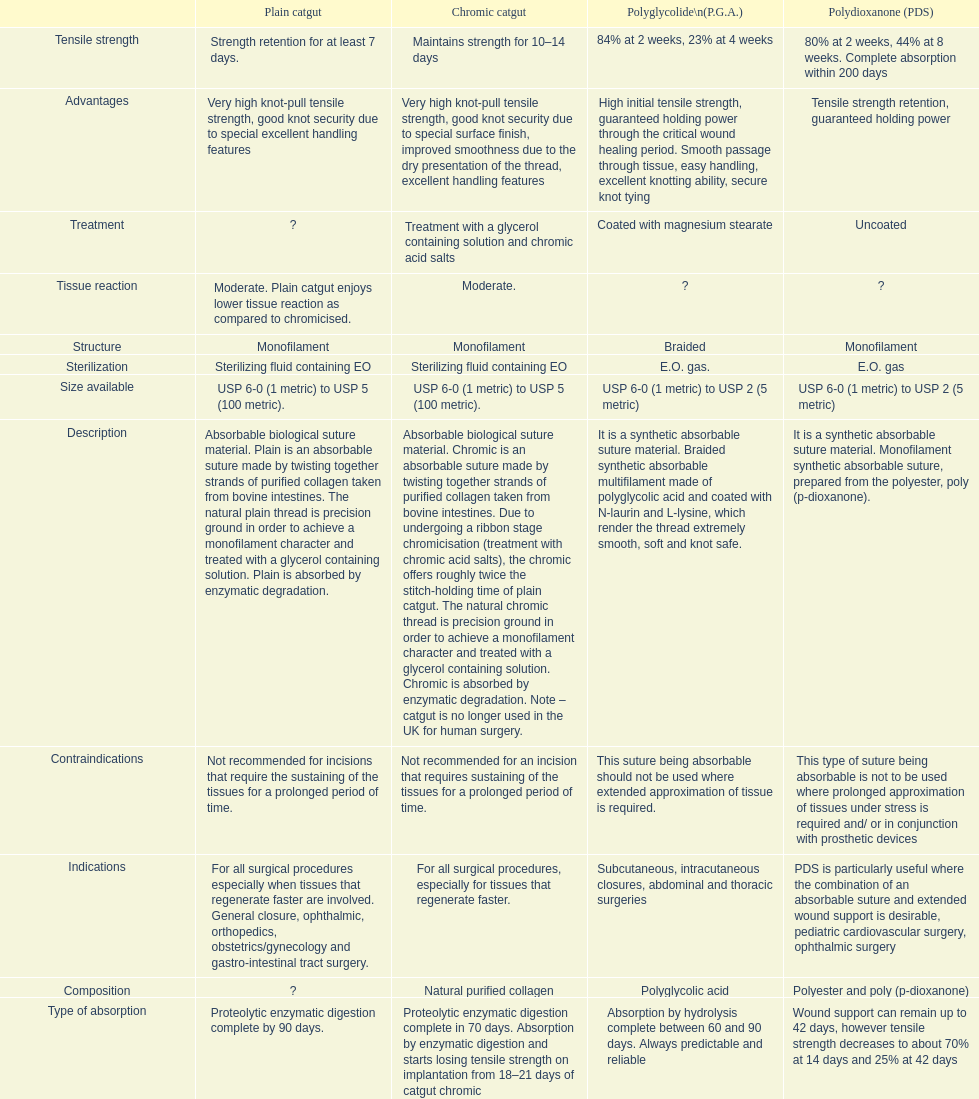What type of sutures are no longer used in the u.k. for human surgery? Chromic catgut. 